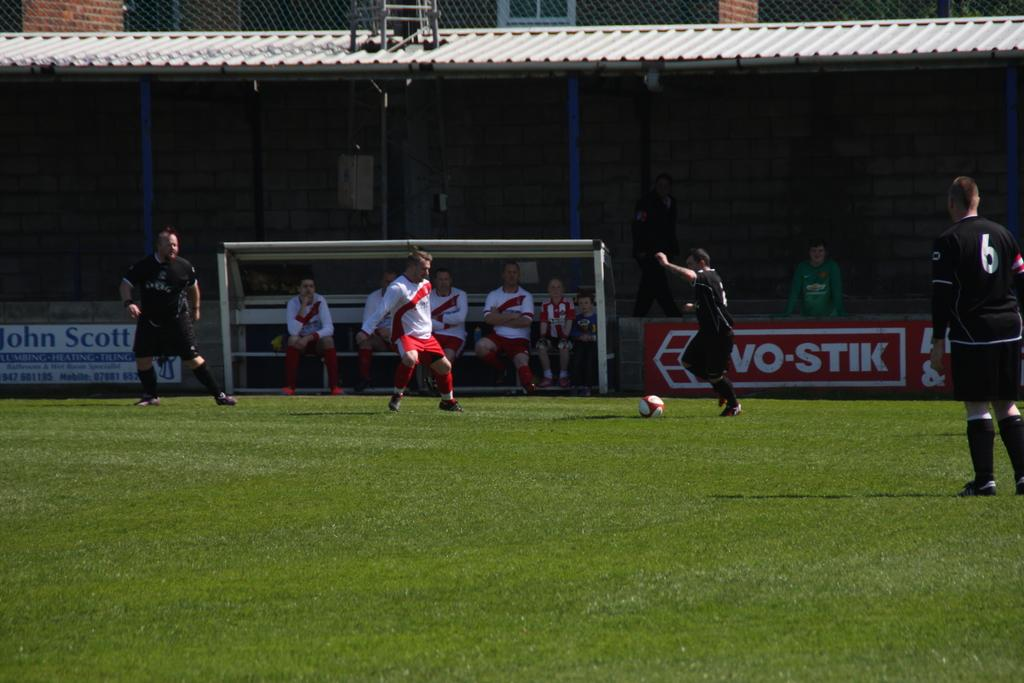<image>
Render a clear and concise summary of the photo. A soccer player is about to kick the ball toward the goal with the logo for john scott visible in the background. 